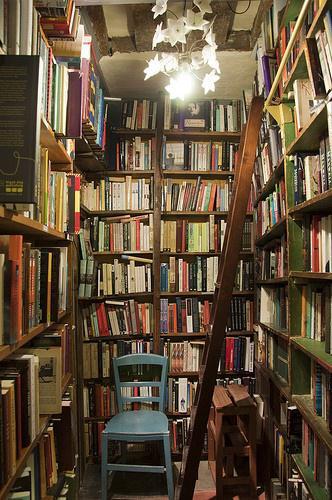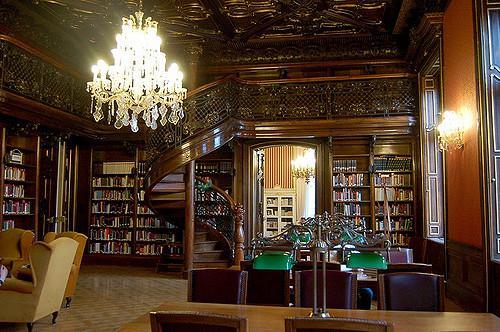The first image is the image on the left, the second image is the image on the right. Given the left and right images, does the statement "One image shows the exterior of a book shop." hold true? Answer yes or no. No. The first image is the image on the left, the second image is the image on the right. For the images displayed, is the sentence "One of the images shows the outside of a bookstore." factually correct? Answer yes or no. No. 